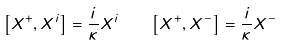<formula> <loc_0><loc_0><loc_500><loc_500>\left [ X ^ { + } , X ^ { i } \right ] = \frac { i } { \kappa } X ^ { i } \quad \left [ X ^ { + } , X ^ { - } \right ] = \frac { i } { \kappa } X ^ { - }</formula> 